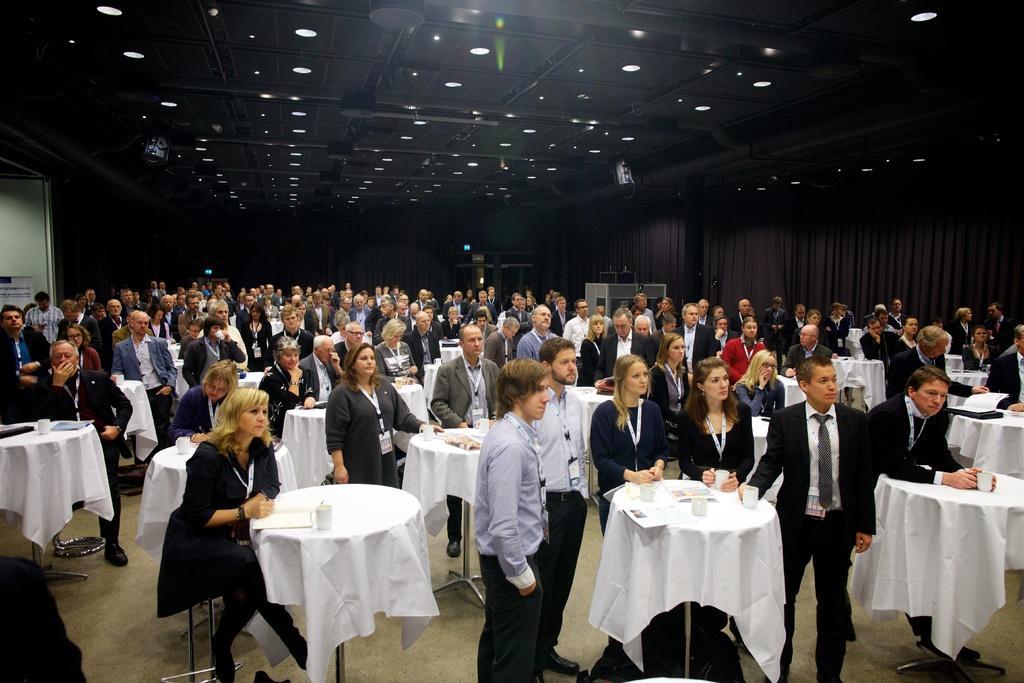Could you give a brief overview of what you see in this image? In this image there are group of people. There are cups, papers on the table. Table is covered with white color cloth. At the right there are curtains, at the top there are lights. 